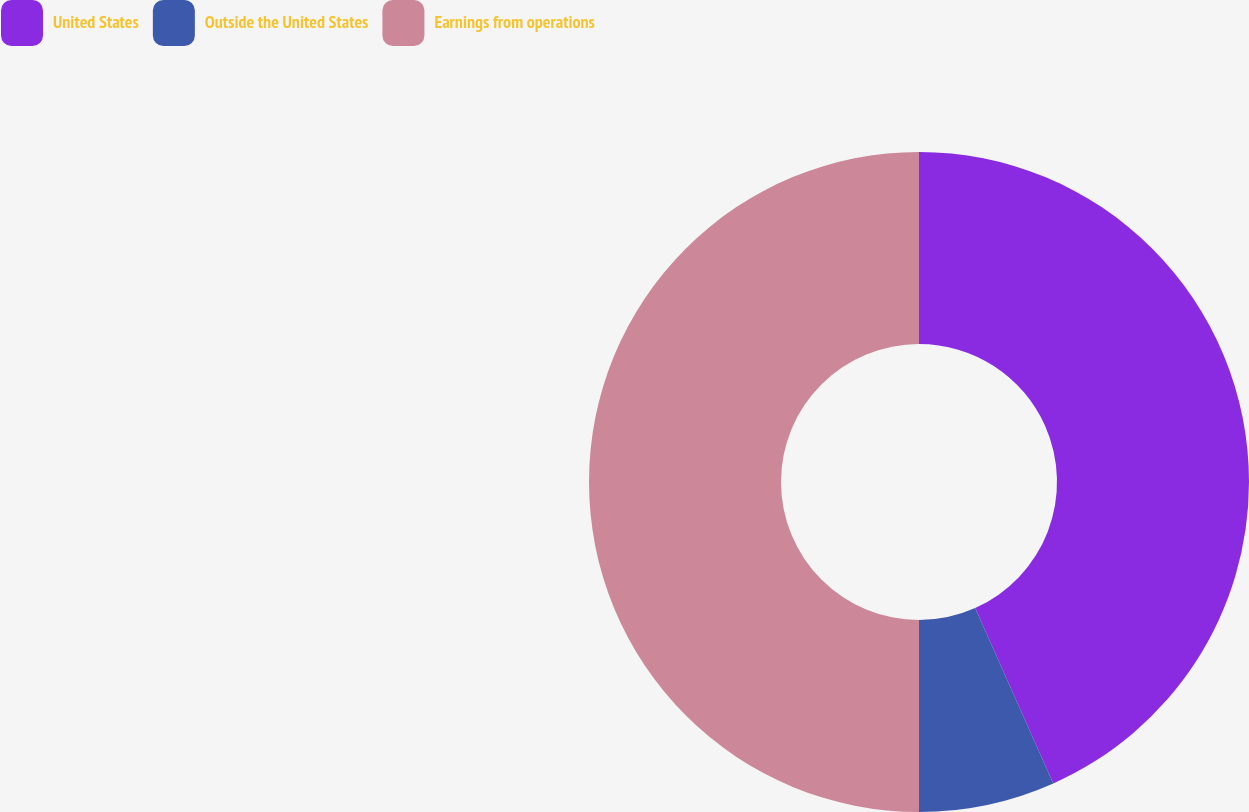Convert chart to OTSL. <chart><loc_0><loc_0><loc_500><loc_500><pie_chart><fcel>United States<fcel>Outside the United States<fcel>Earnings from operations<nl><fcel>43.33%<fcel>6.67%<fcel>50.0%<nl></chart> 